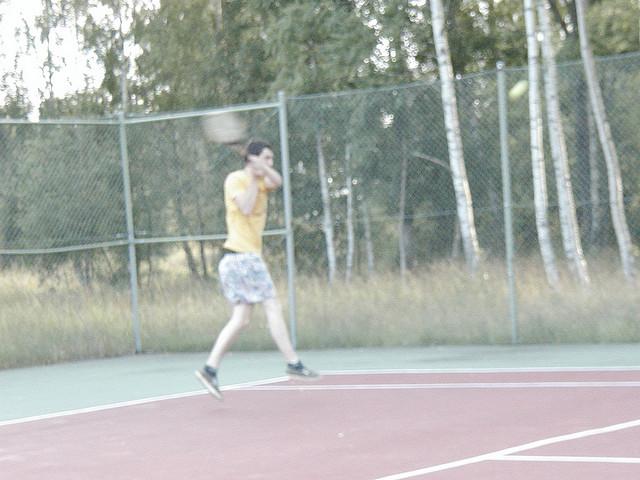Is there a fence around the court?
Keep it brief. Yes. Is this a professional game?
Short answer required. No. Is this blurry?
Answer briefly. Yes. 